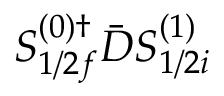Convert formula to latex. <formula><loc_0><loc_0><loc_500><loc_500>S _ { 1 / 2 f } ^ { ( 0 ) \dagger } \bar { D } S _ { 1 / 2 i } ^ { ( 1 ) }</formula> 